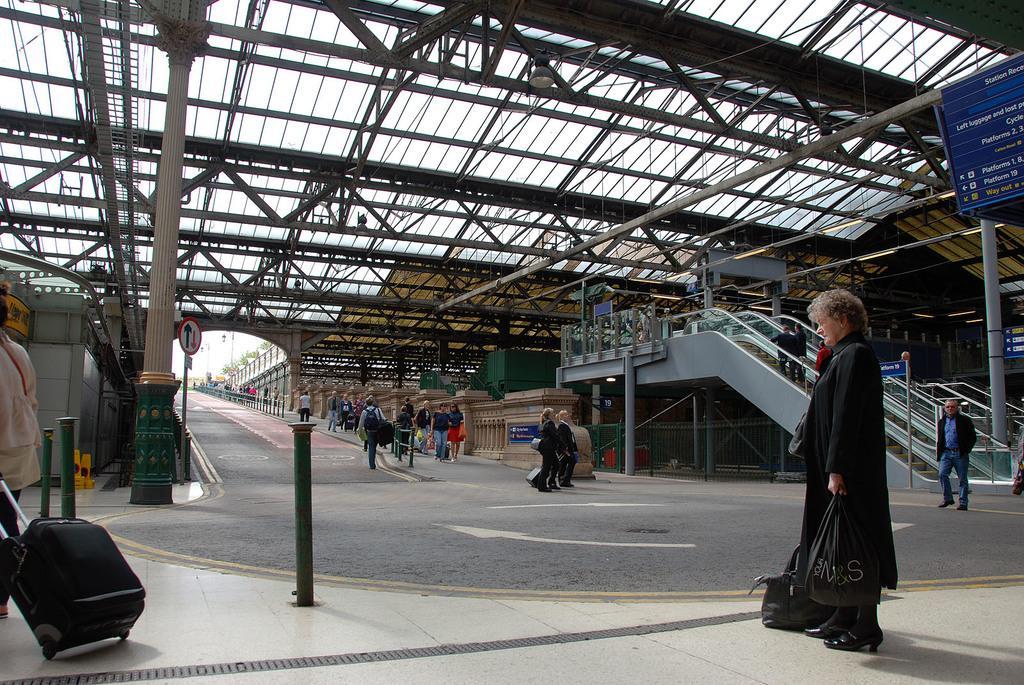Could you give a brief overview of what you see in this image? There are group of people standing on the either side of the road and there is an escalator in the background. 